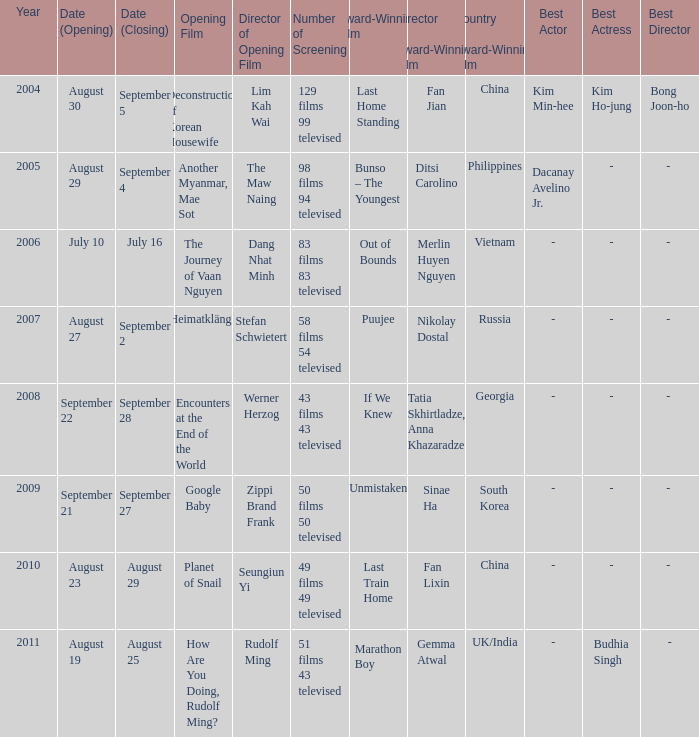What is the number of acclaimed films that include the opening of encounters at the end of the world? 1.0. 